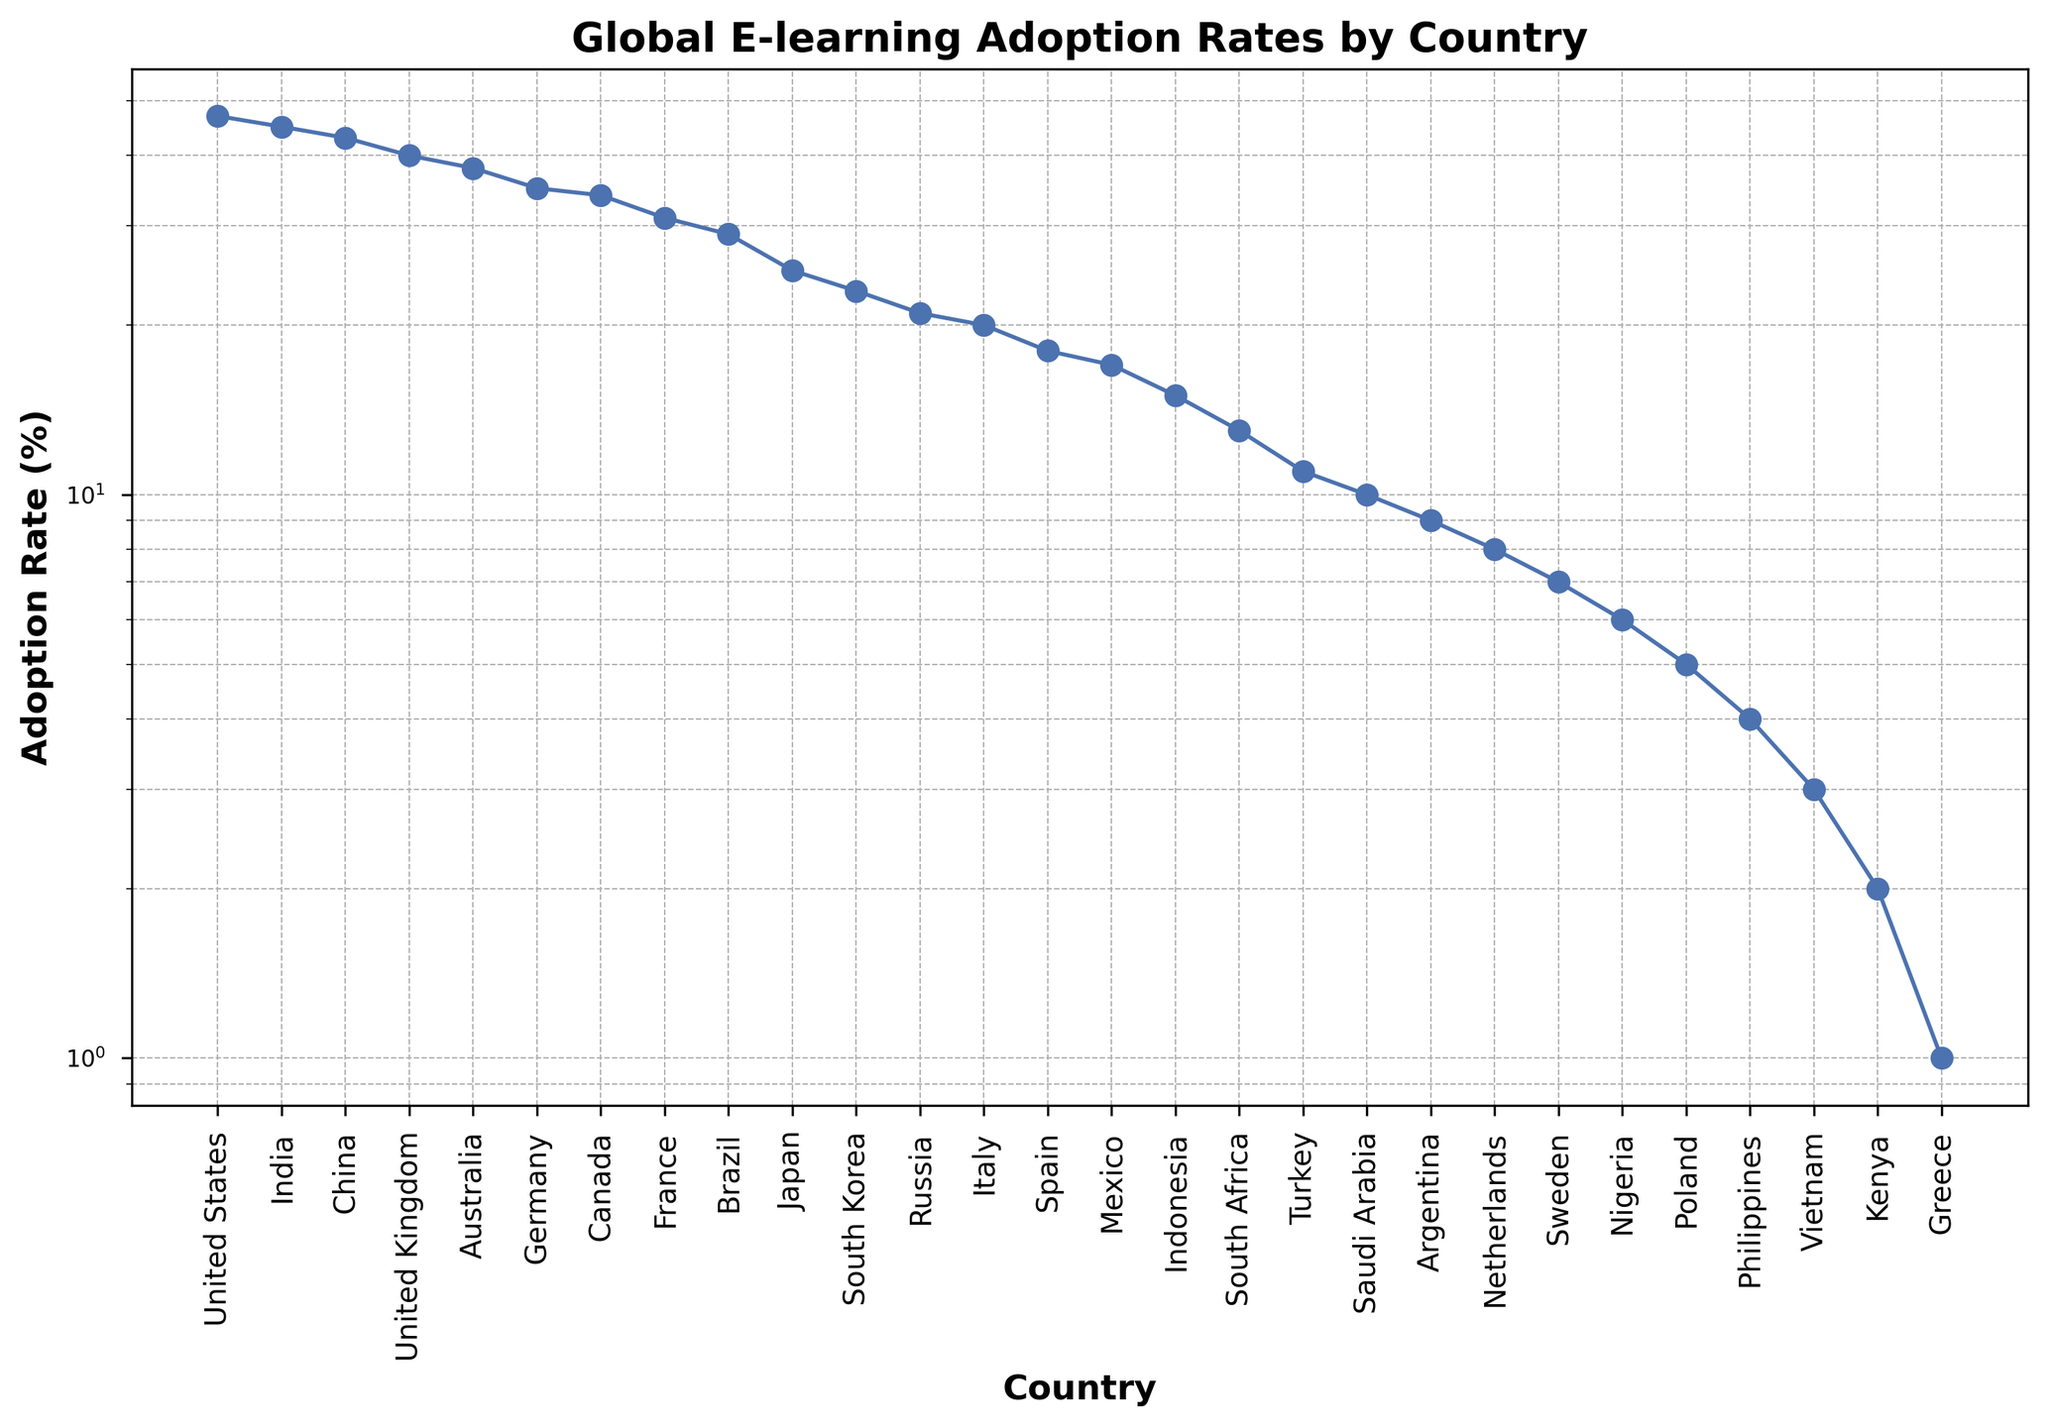Which country has the highest e-learning adoption rate? By comparing the data points on the chart, we see that the United States has the highest adoption rate.
Answer: United States Which country has the lowest e-learning adoption rate? By looking at the bottom of the chart, we can identify that Greece has the lowest adoption rate.
Answer: Greece What is the adoption rate difference between the United States and China? United States has an adoption rate of 47%, and China has 43%. The difference is 47 - 43 = 4%.
Answer: 4% Which countries have an adoption rate greater than 40%? By observing the Y-axis (log scale) and corresponding countries, the United States, India, China, and the United Kingdom have adoption rates above 40%.
Answer: United States, India, China, United Kingdom What's the average e-learning adoption rate of the countries with rates below 10%? Countries with rates below 10% are Argentina (9), Netherlands (8), Sweden (7), Nigeria (6), Poland (5), Philippines (4), Vietnam (3), Kenya (2), and Greece (1). Sum = 45, Number of countries = 9, so average = 45 / 9 = 5.
Answer: 5 Is the adoption rate of Germany greater than that of France and Canada combined? Germany's rate is 35%. France's rate is 31%, and Canada's rate is 34%. Combined rate of France and Canada is 31 + 34 = 65%. Germany's rate is not greater than 65%.
Answer: No Which country between Italy and Spain has a higher adoption rate, and by how much? Comparing Italy (20%) and Spain (18%), Italy has a higher rate. The difference is 20 - 18 = 2%.
Answer: Italy, 2% What's the visual trend in adoption rates as we move from the United States to Greece on the X-axis? Visually, the trend shows a general decline in e-learning adoption rates from left (United States) to right (Greece).
Answer: Decline Which country has an e-learning adoption rate nearest to 30%? By observing the Y-axis and corresponding countries, France has an adoption rate closest to 30% with 31%.
Answer: France Between South Korea and Russia, which has a lower adoption rate and by what percentage? South Korea has a 23% adoption rate, and Russia has 21%. The difference is 23 - 21 = 2%.
Answer: Russia, 2% 